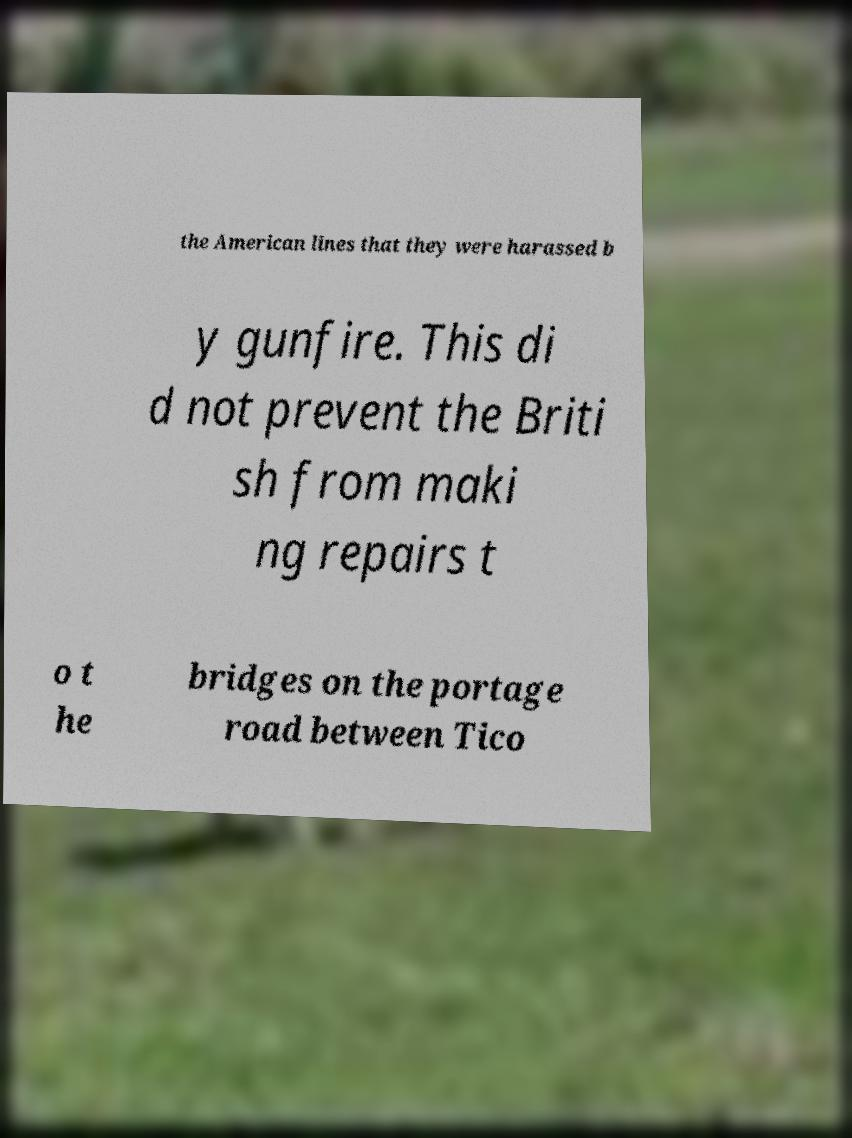Please identify and transcribe the text found in this image. the American lines that they were harassed b y gunfire. This di d not prevent the Briti sh from maki ng repairs t o t he bridges on the portage road between Tico 